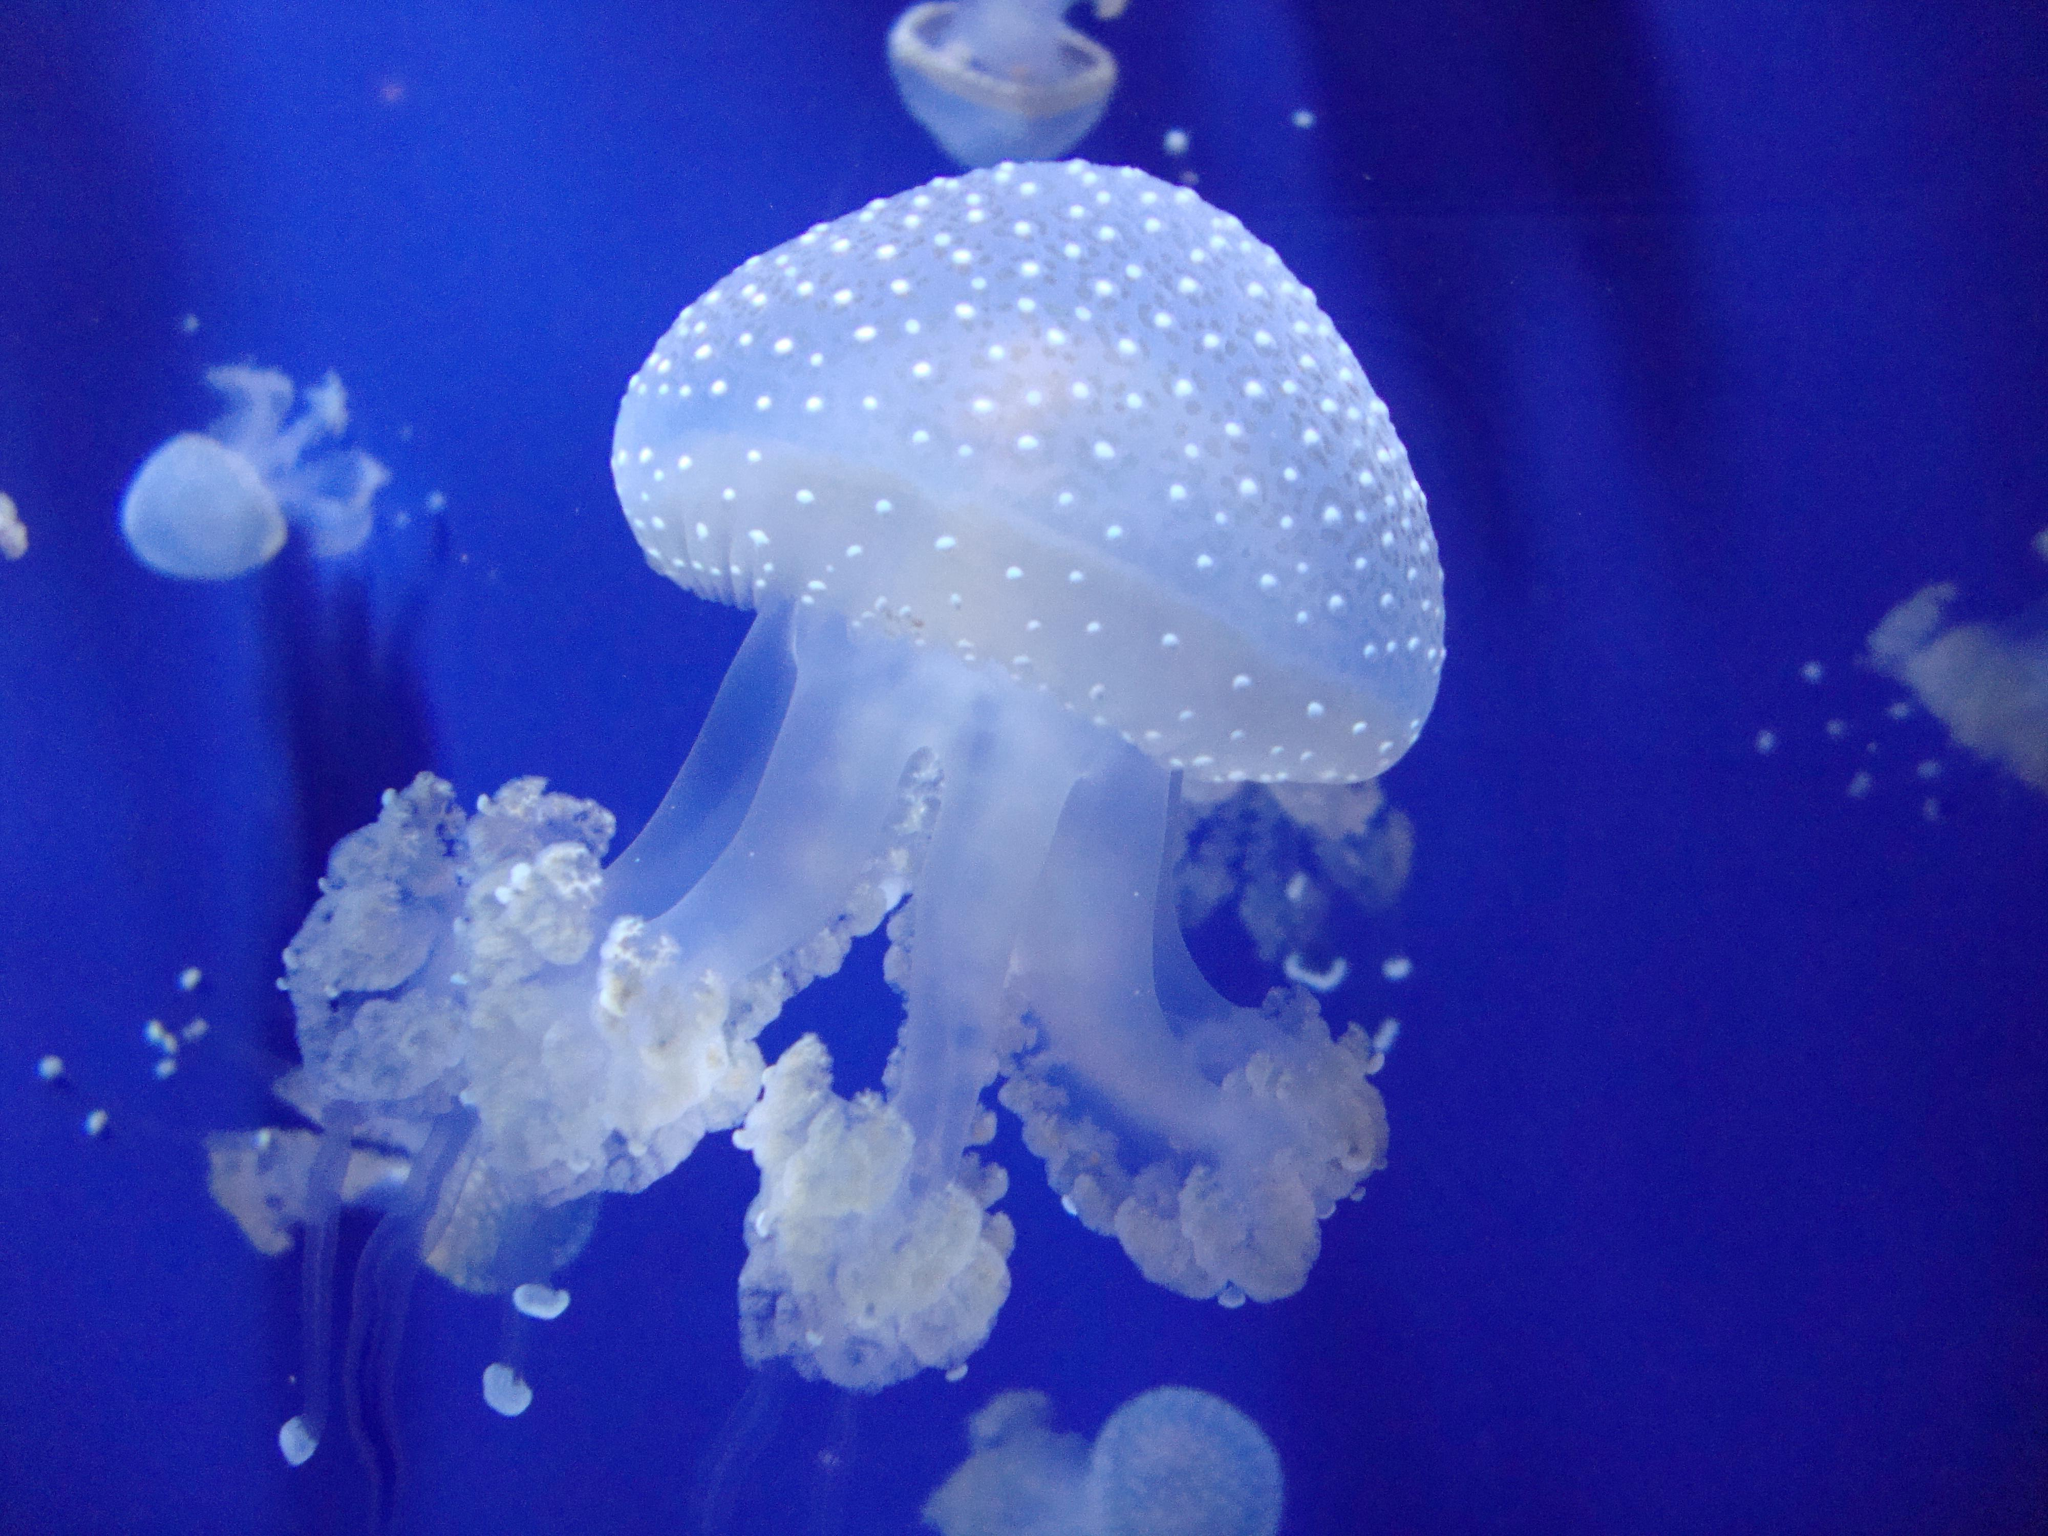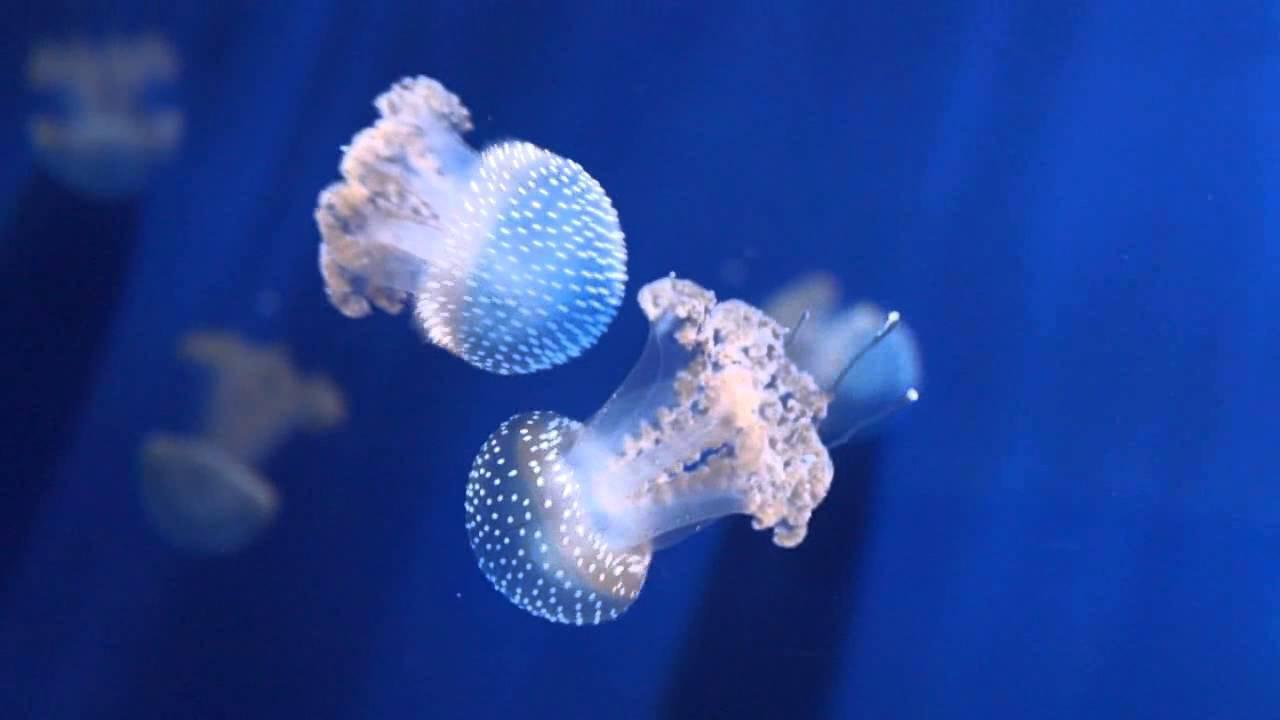The first image is the image on the left, the second image is the image on the right. Examine the images to the left and right. Is the description "Foreground of the right image shows exactly two polka-dotted mushroom-shaped jellyfish with frilly tendrils." accurate? Answer yes or no. Yes. The first image is the image on the left, the second image is the image on the right. Considering the images on both sides, is "Some jellyfish are traveling downwards." valid? Answer yes or no. Yes. 